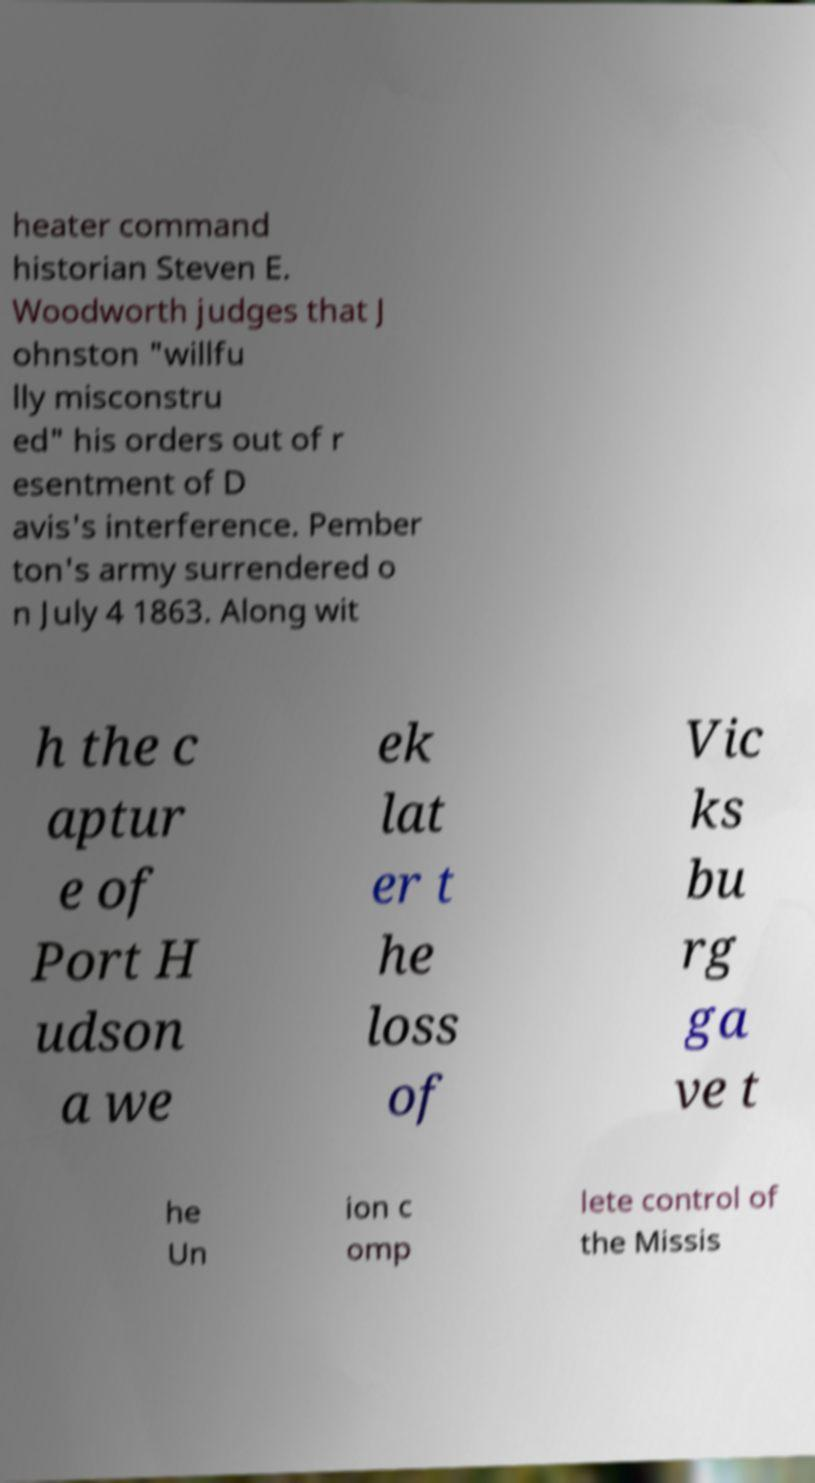Could you extract and type out the text from this image? heater command historian Steven E. Woodworth judges that J ohnston "willfu lly misconstru ed" his orders out of r esentment of D avis's interference. Pember ton's army surrendered o n July 4 1863. Along wit h the c aptur e of Port H udson a we ek lat er t he loss of Vic ks bu rg ga ve t he Un ion c omp lete control of the Missis 